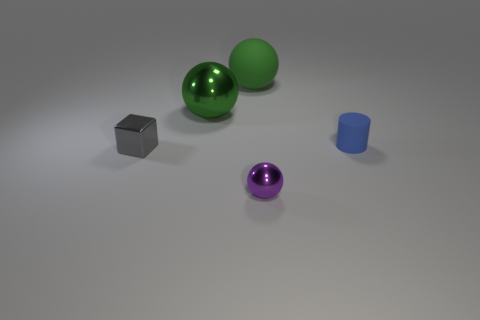Subtract all large green matte spheres. How many spheres are left? 2 Subtract all blue cylinders. How many green spheres are left? 2 Add 3 gray metal things. How many objects exist? 8 Subtract all cylinders. How many objects are left? 4 Subtract all cyan metallic cylinders. Subtract all metallic things. How many objects are left? 2 Add 5 small blue matte cylinders. How many small blue matte cylinders are left? 6 Add 1 tiny brown metal things. How many tiny brown metal things exist? 1 Subtract 0 cyan cylinders. How many objects are left? 5 Subtract all green cylinders. Subtract all gray spheres. How many cylinders are left? 1 